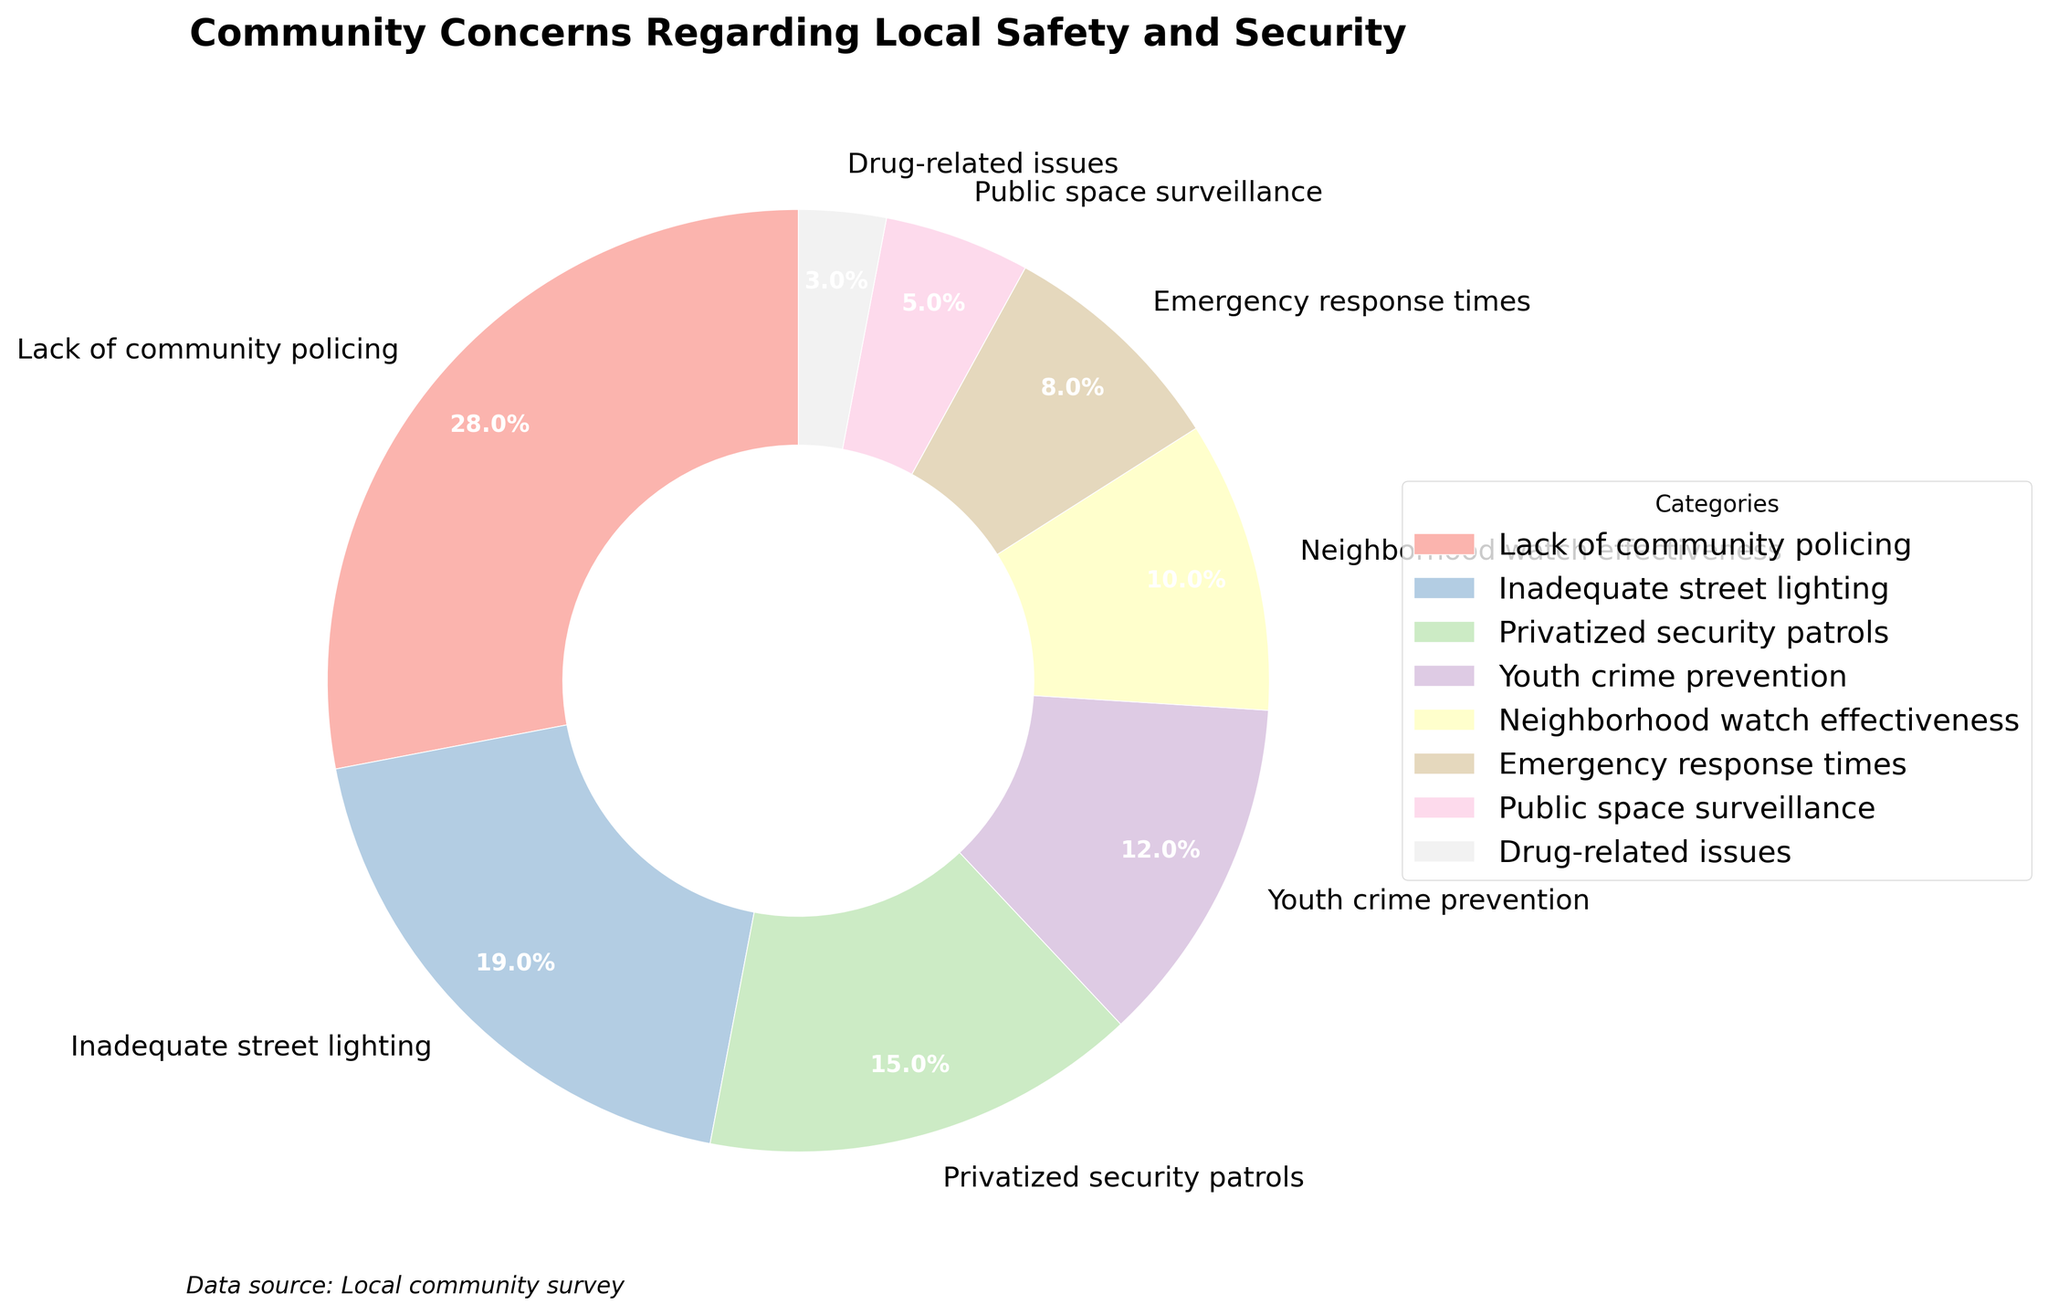Which category has the highest concern percentage? To find the category with the highest concern percentage, look at the pie chart segments and their corresponding labels and percentages. The largest segment represents the category with the highest concern.
Answer: Lack of community policing What is the combined percentage of concerns related to 'Privatized security patrols' and 'Youth crime prevention'? Identify the percentages for 'Privatized security patrols' (15%) and 'Youth crime prevention' (12%), then sum them up: 15% + 12% = 27%.
Answer: 27% Which concern category has a smaller percentage of concern than 'Youth crime prevention' but larger than 'Public space surveillance'? Identify the percentage of 'Youth crime prevention' (12%) and 'Public space surveillance' (5%), then look for a category that falls in between these percentages. 'Neighborhood watch effectiveness' has 10%, which fits this criterion.
Answer: Neighborhood watch effectiveness If you group 'Inadequate street lighting' and 'Emergency response times', how does their total percentage compare to 'Lack of community policing'? Find the percentages of 'Inadequate street lighting' (19%) and 'Emergency response times' (8%), then sum them up: 19% + 8% = 27%. Compare it to the percentage of 'Lack of community policing' (28%). 27% is slightly less than 28%.
Answer: Slightly less What is the percentage difference between 'Drug-related issues' and 'Inadequate street lighting'? Identify the percentages for 'Drug-related issues' (3%) and 'Inadequate street lighting' (19%), then subtract the smaller percentage from the larger one: 19% - 3% = 16%.
Answer: 16% Arrange the concern categories in descending order based on their percentages. List the categories with their percentages and order them from highest to lowest: 'Lack of community policing' (28%), 'Inadequate street lighting' (19%), 'Privatized security patrols' (15%), 'Youth crime prevention' (12%), 'Neighborhood watch effectiveness' (10%), 'Emergency response times' (8%), 'Public space surveillance' (5%), 'Drug-related issues' (3%).
Answer: Lack of community policing, Inadequate street lighting, Privatized security patrols, Youth crime prevention, Neighborhood watch effectiveness, Emergency response times, Public space surveillance, Drug-related issues What percentage of the chart is occupied by concerns related to 'Emergency response times' and 'Drug-related issues' together? Add the percentages of 'Emergency response times' (8%) and 'Drug-related issues' (3%): 8% + 3% = 11%.
Answer: 11% Which segment on the pie chart has the lightest color shade? Visually inspect the pie chart for the segment with the lightest color. Generally, lighter colors appear softer and closer to white.
Answer: Drug-related issues 